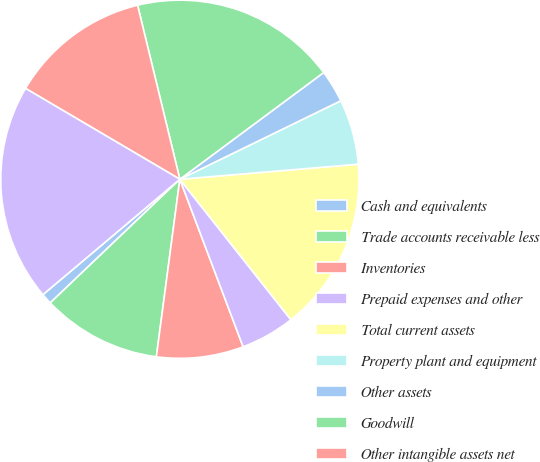Convert chart. <chart><loc_0><loc_0><loc_500><loc_500><pie_chart><fcel>Cash and equivalents<fcel>Trade accounts receivable less<fcel>Inventories<fcel>Prepaid expenses and other<fcel>Total current assets<fcel>Property plant and equipment<fcel>Other assets<fcel>Goodwill<fcel>Other intangible assets net<fcel>Total assets<nl><fcel>0.98%<fcel>10.78%<fcel>7.84%<fcel>4.9%<fcel>15.69%<fcel>5.88%<fcel>2.94%<fcel>18.63%<fcel>12.74%<fcel>19.61%<nl></chart> 